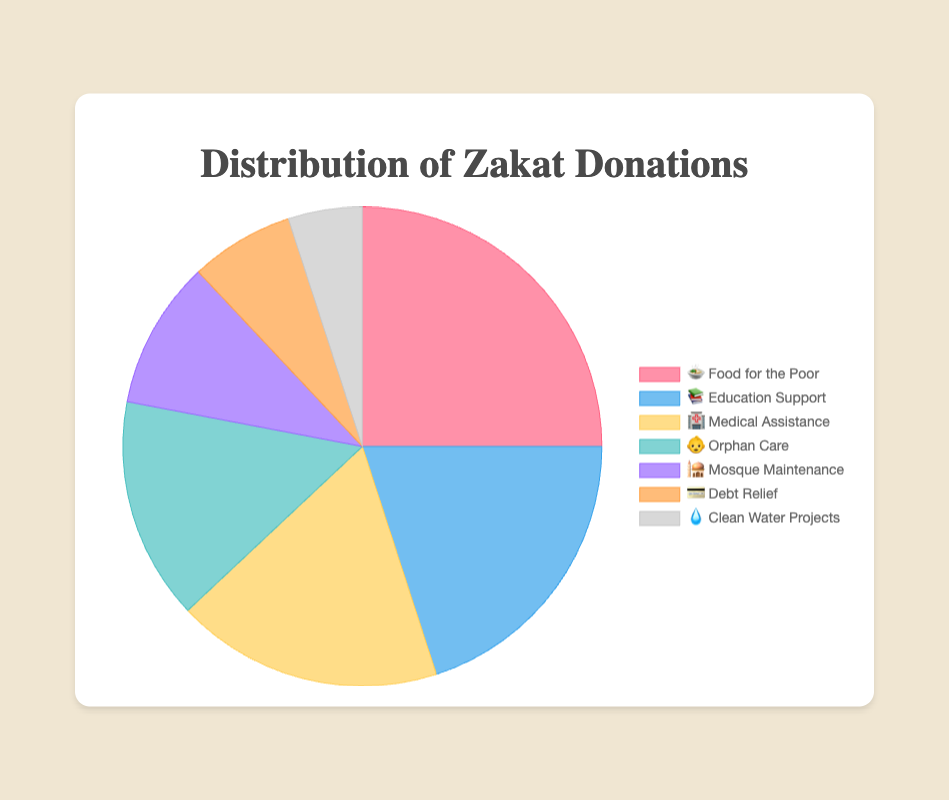What's the title of the chart? The title of the chart is displayed prominently at the top of the chart. It reads "Distribution of Zakat Donations".
Answer: Distribution of Zakat Donations Which category received the highest percentage of zakat donations? The largest section in the pie chart, identified both by size and the percentage label, represents "🍲 Food for the Poor" with 25%.
Answer: Food for the Poor What percentage of zakat donations went to Clean Water Projects? Looking at the smallest segment in the pie chart, represented by "💧 Clean Water Projects", it is labeled with a percentage indicating 5%.
Answer: 5% How much more percentage does Medical Assistance receive compared to Mosque Maintenance? Medical Assistance is 18% and Mosque Maintenance is 10%. Calculating the difference: 18% - 10% = 8%
Answer: 8% Which two categories together receive exactly 35% of donations? By examining the chart, we see that combining "Mosque Maintenance" (10%) and "Debt Relief" (7%) totals 17%, while "Medical Assistance" (18%) and "Clean Water Projects" (5%) total 23%. By combining "Education Support" (20%) and "Mosque Maintenance" (10%), we initially see a miscalculation as it totals 30%. However, "Orphan Care" (15%) and "Mosque Maintenance" (10%) together total 25%, still not 35%. The closest match to 35% are "Education Support" (20%) and "Orphan Care" (15%).
Answer: Education Support, Orphan Care Which category received the smallest percentage of zakat donations? Observing the smallest piece of the pie chart identifies "💧 Clean Water Projects" as receiving the smallest percentage, at 5%.
Answer: Clean Water Projects How many categories receive less than 20% of the total donations? Categories receiving less than 20% are '🏥 Medical Assistance' (18%), '👶 Orphan Care' (15%), '🕌 Mosque Maintenance' (10%), '💳 Debt Relief' (7%), and '💧 Clean Water Projects' (5%). Counting these categories we get five.
Answer: 5 What percentage did not go to Food for the Poor? Food for the Poor received 25%. Subtracting this from 100%: 100% - 25% = 75%.
Answer: 75% If donations for Orphan Care and Debt Relief were combined, what would the total percentage be? Summing the donations for Orphan Care (15%) and Debt Relief (7%): 15% + 7% = 22%.
Answer: 22% Rank the top three categories in descending order by percentage donations. Reviewing the chart, the top three categories by percentage are: 1. Food for the Poor (25%), 2. Education Support (20%), 3. Medical Assistance (18%).
Answer: 1. Food for the Poor, 2. Education Support, 3. Medical Assistance 